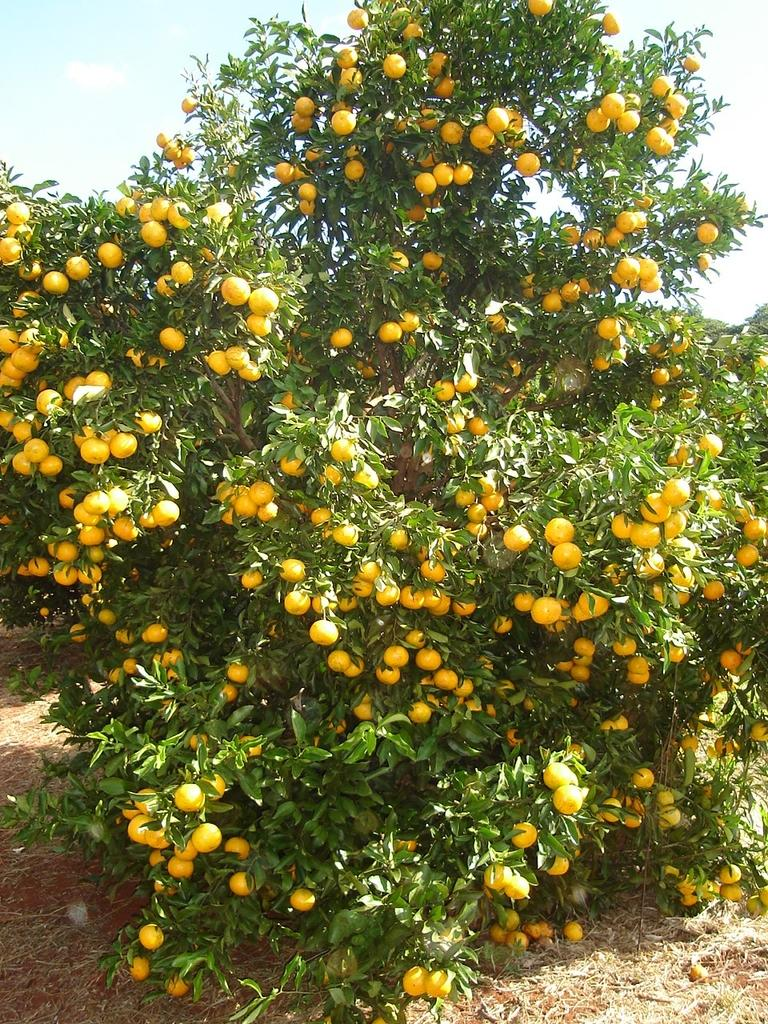What type of plant is present in the image? There is a tree with fruits in the image. What can be seen in the background of the image? The sky is visible in the background of the image. What type of vegetation is at the bottom of the image? There is grass at the bottom of the image. What is visible at the bottom of the image? The ground is visible at the bottom of the image. How many rose petals are scattered on the ground in the image? There are no rose petals present in the image; it features a tree with fruits, grass, and the sky. 